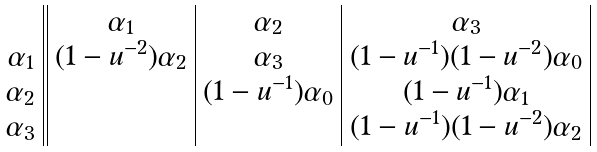<formula> <loc_0><loc_0><loc_500><loc_500>\begin{array} { c | | c | c | c | } & \alpha _ { 1 } & \alpha _ { 2 } & \alpha _ { 3 } \\ \alpha _ { 1 } & ( 1 - u ^ { - 2 } ) \alpha _ { 2 } & \alpha _ { 3 } & ( 1 - u ^ { - 1 } ) ( 1 - u ^ { - 2 } ) \alpha _ { 0 } \\ \alpha _ { 2 } & & ( 1 - u ^ { - 1 } ) \alpha _ { 0 } & ( 1 - u ^ { - 1 } ) \alpha _ { 1 } \\ \alpha _ { 3 } & & & ( 1 - u ^ { - 1 } ) ( 1 - u ^ { - 2 } ) \alpha _ { 2 } \\ \end{array}</formula> 